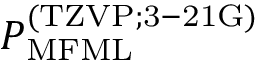<formula> <loc_0><loc_0><loc_500><loc_500>P _ { M F M L } ^ { ( T Z V P ; 3 - 2 1 G ) }</formula> 